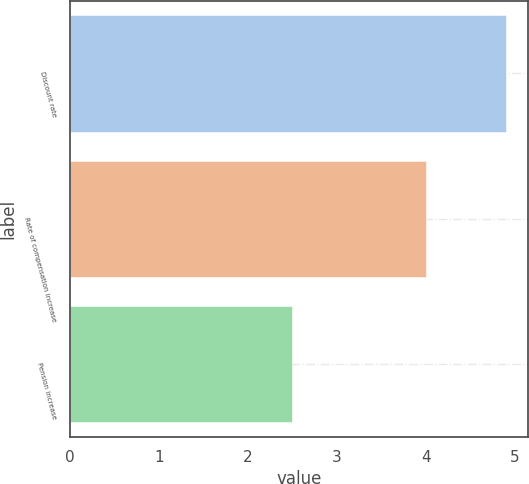<chart> <loc_0><loc_0><loc_500><loc_500><bar_chart><fcel>Discount rate<fcel>Rate of compensation increase<fcel>Pension increase<nl><fcel>4.9<fcel>4<fcel>2.5<nl></chart> 